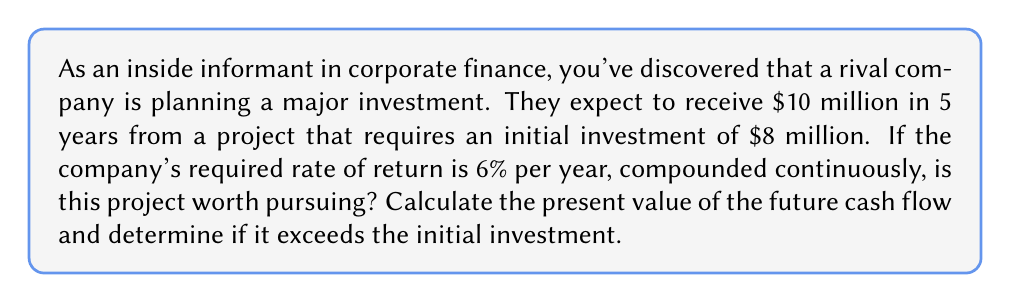What is the answer to this math problem? To solve this problem, we need to use the continuous compound interest formula and compare the present value of the future cash flow to the initial investment.

1. The continuous compound interest formula is:
   $$PV = FV \cdot e^{-rt}$$
   Where:
   PV = Present Value
   FV = Future Value
   r = Interest rate (as a decimal)
   t = Time (in years)
   e = Euler's number (approximately 2.71828)

2. We have:
   FV = $10 million
   r = 6% = 0.06
   t = 5 years

3. Let's substitute these values into the formula:
   $$PV = 10,000,000 \cdot e^{-0.06 \cdot 5}$$

4. Simplify the exponent:
   $$PV = 10,000,000 \cdot e^{-0.3}$$

5. Calculate the value (using a calculator):
   $$PV = 10,000,000 \cdot 0.7408182$$
   $$PV = 7,408,182$$

6. Compare this present value to the initial investment:
   Present Value = $7,408,182
   Initial Investment = $8,000,000

7. Since the present value ($7,408,182) is less than the initial investment ($8,000,000), the project is not worth pursuing based on the given information and required rate of return.
Answer: $7,408,182; No 